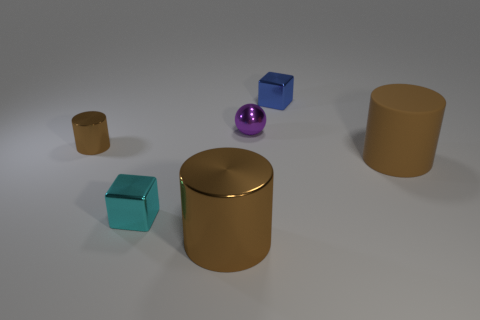Subtract all brown cylinders. How many were subtracted if there are1brown cylinders left? 2 Subtract all metal cylinders. How many cylinders are left? 1 Add 1 large cylinders. How many objects exist? 7 Subtract all spheres. How many objects are left? 5 Subtract 0 brown cubes. How many objects are left? 6 Subtract all blue metal cylinders. Subtract all tiny purple balls. How many objects are left? 5 Add 5 metallic things. How many metallic things are left? 10 Add 2 metal cylinders. How many metal cylinders exist? 4 